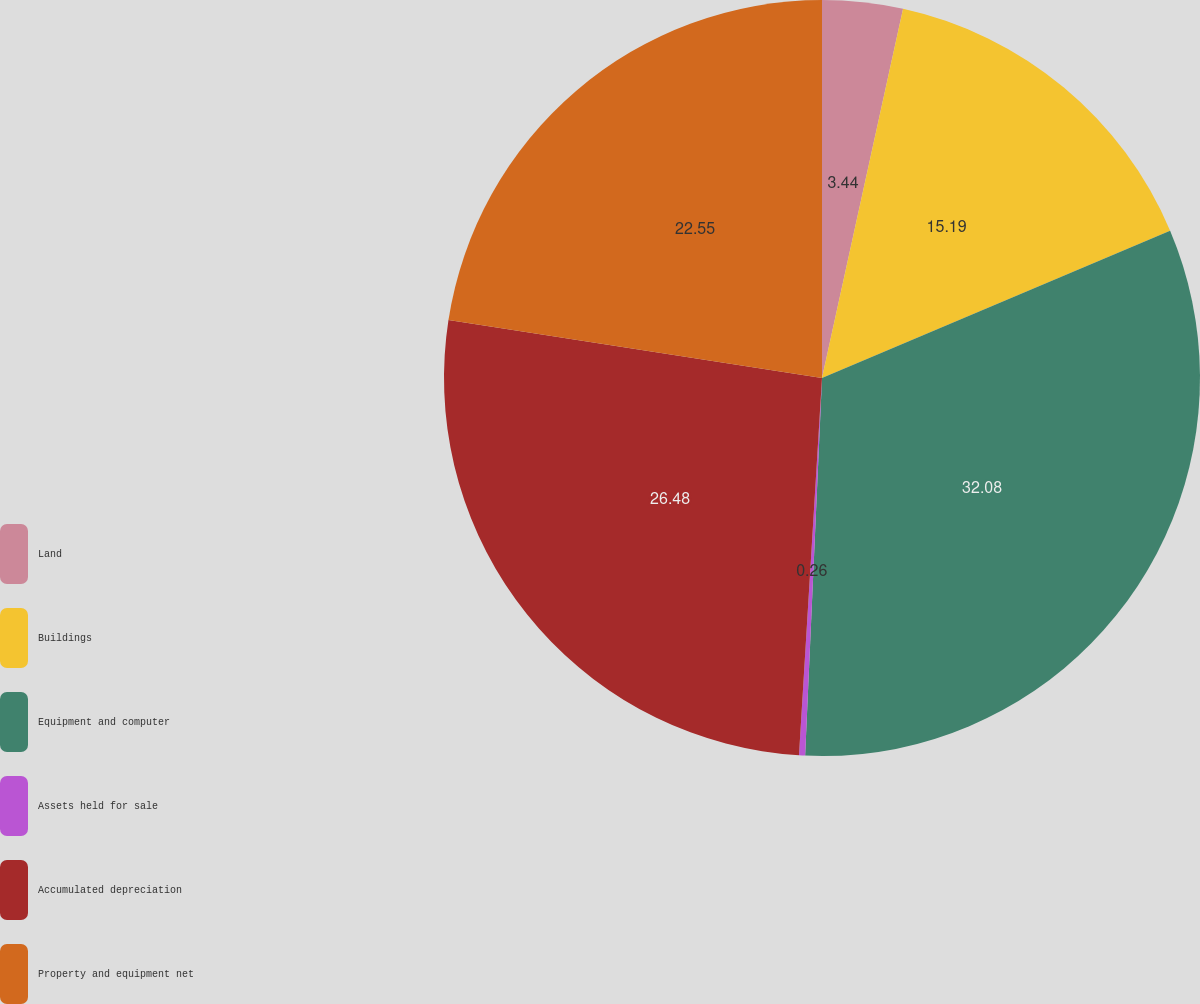Convert chart to OTSL. <chart><loc_0><loc_0><loc_500><loc_500><pie_chart><fcel>Land<fcel>Buildings<fcel>Equipment and computer<fcel>Assets held for sale<fcel>Accumulated depreciation<fcel>Property and equipment net<nl><fcel>3.44%<fcel>15.19%<fcel>32.08%<fcel>0.26%<fcel>26.48%<fcel>22.55%<nl></chart> 